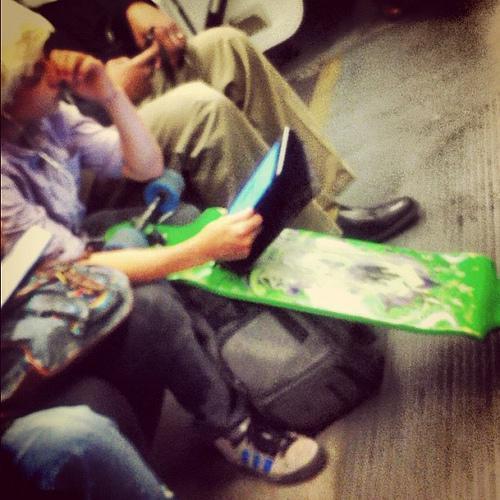How many people are in this photo?
Give a very brief answer. 3. 